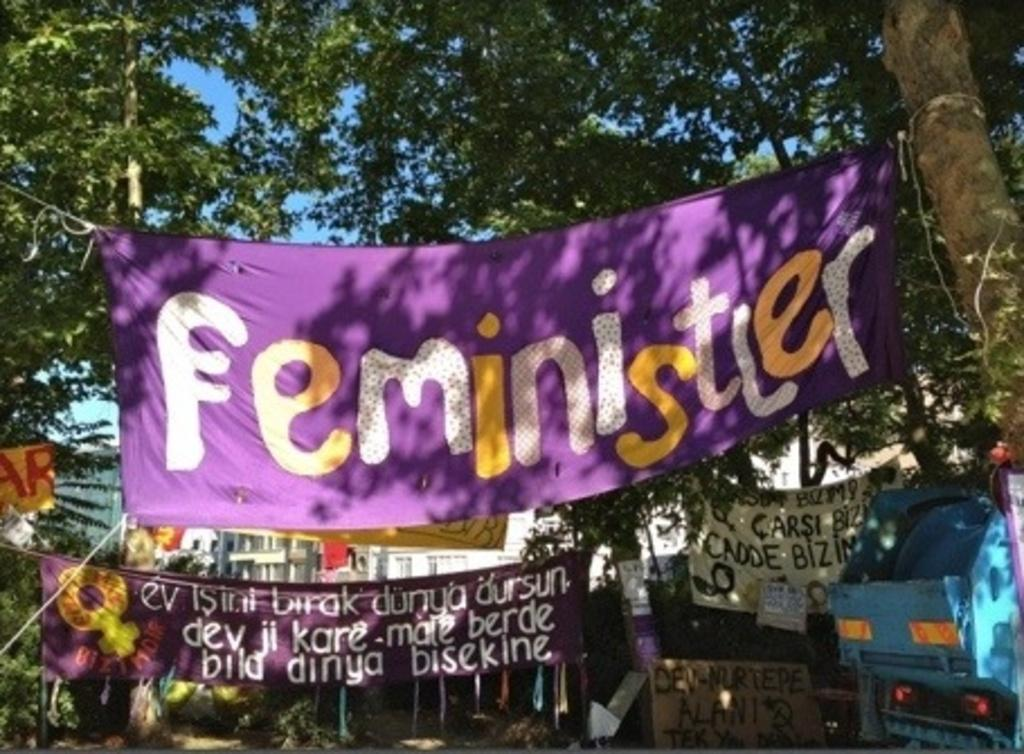What type of natural elements can be seen in the image? There are trees in the image. What type of man-made structures are visible in the image? There are buildings in the image. What are the banners used for in the image? The banners are present in the image, but their purpose is not specified. What are the poles supporting in the image? The poles are visible in the image, but their purpose is not specified. What are the boards used for in the image? The boards are in the image, but their purpose is not specified. What type of vehicle is present in the image? There is a vehicle in the image. What color are the trousers worn by the chin in the image? There are no trousers or chins present in the image. What is the cause of the conflict between the trees and the buildings in the image? There is no conflict between the trees and the buildings in the image; they coexist peacefully. 